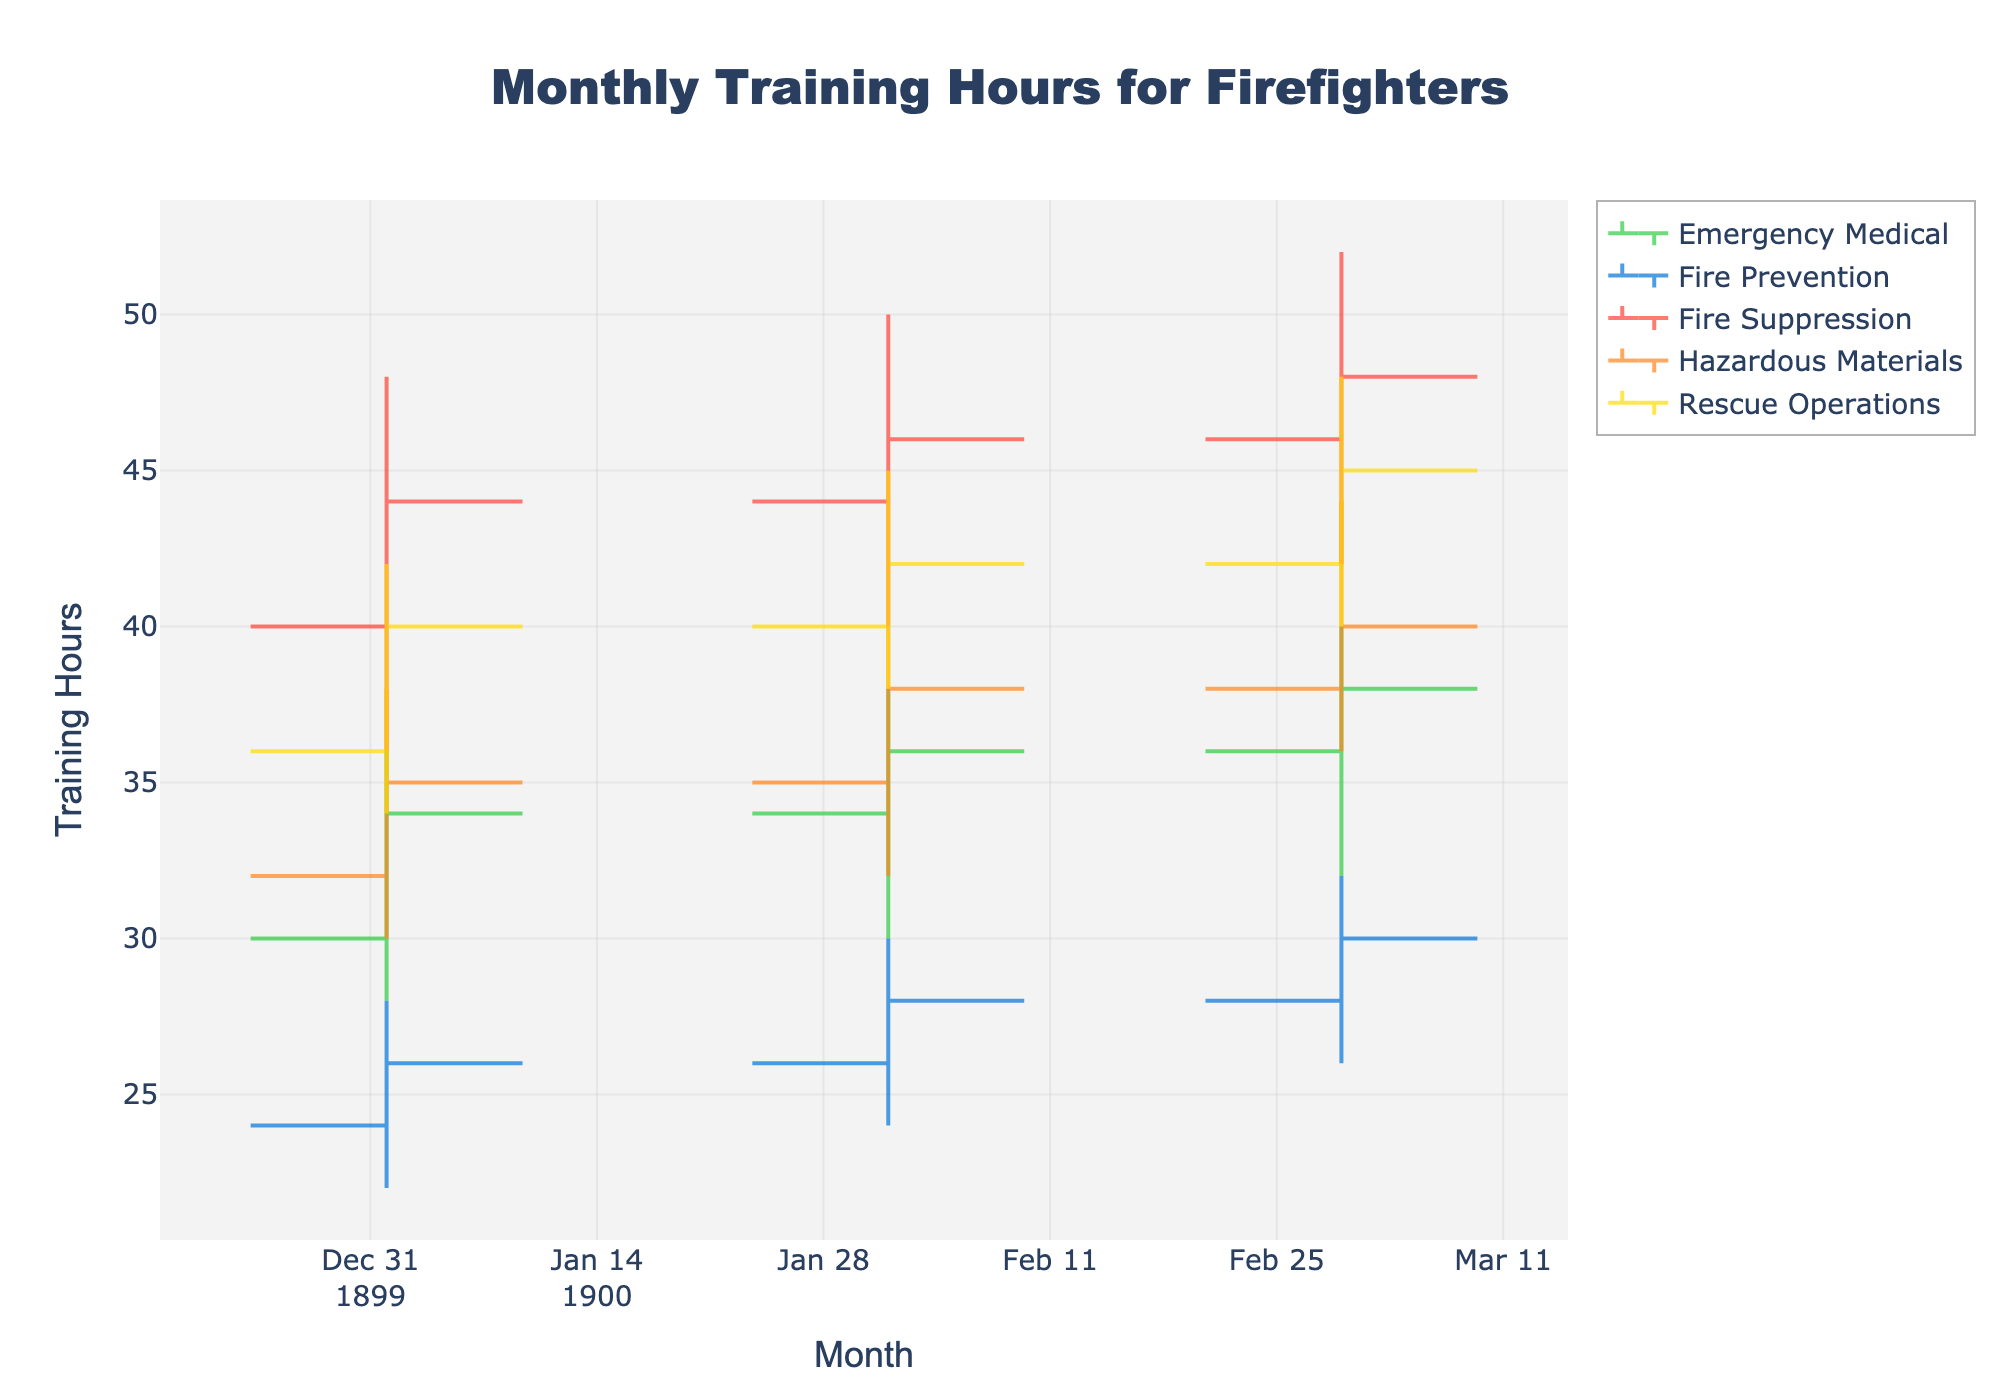What's the title of the chart? The title of the chart is usually located at the top of the figure. The title of this chart is "Monthly Training Hours for Firefighters".
Answer: Monthly Training Hours for Firefighters Which specialization had the highest training hours high point in March? To find this, look at the "High" values for March across all specializations. "Fire Suppression" had a high point of 52, which is the highest.
Answer: Fire Suppression How many specializations are shown in the figure? Count the unique specializations listed in the chart. The unique specializations are "Fire Suppression," "Hazardous Materials," "Rescue Operations," "Emergency Medical," and "Fire Prevention."
Answer: 5 What is the average close value for Fire Suppression across the three months? To find the average close value for Fire Suppression, sum the close values for January, February, and March, and then divide by 3. (44 + 46 + 48) / 3 = 138 / 3 = 46.
Answer: 46 How does the close value for Emergency Medical compare from January to February? To compare the close values, subtract the close value in January from the close value in February. The January close value is 34 and the February close value is 36. 36 - 34 = 2, so it increased by 2 hours.
Answer: Increased by 2 hours Which specialization has the smallest range between the high and low values in February? Calculate the range (high - low) for each specialization in February. Fire Suppression: 50-40 = 10, Hazardous Materials: 40-32 = 8, Rescue Operations: 45-38 = 7, Emergency Medical: 38-30 = 8, Fire Prevention: 30-24 = 6. Fire Prevention has the smallest range of 6.
Answer: Fire Prevention Which specialization shows an increasing trend in close values from January to March? Examine the close values for each specialization and check if they consistently increased from January to March. Fire Suppression (44, 46, 48) and Rescue Operations (40, 42, 45) both show increasing trends.
Answer: Fire Suppression and Rescue Operations What is the difference between the highest high value and the lowest low value for Hazardous Materials in the data? Find the highest high and the lowest low values for Hazardous Materials. The highest high is in March (44) and the lowest low is in January (30). The difference is 44 - 30 = 14.
Answer: 14 Which specialization had the lowest open value in January? Look at the open values in January and find the lowest value among specializations. The lowest open value is for Fire Prevention at 24.
Answer: Fire Prevention Is there any specialization that had the same close value in two different months? Check if any specialization has the same close values in two different months. Rescue Operations had a close value of 40 in January and also had a close value of 40 in March.
Answer: Rescue Operations 